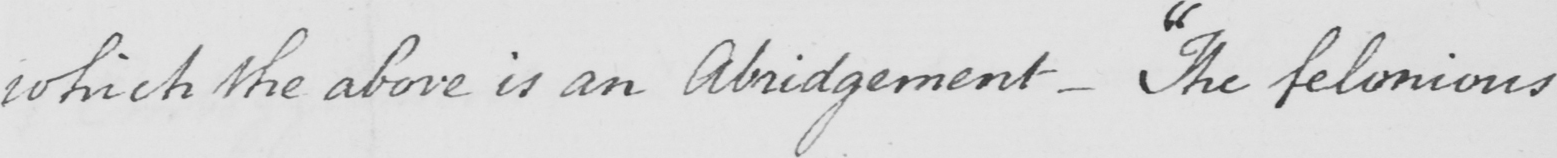What text is written in this handwritten line? which the above in an Abridgement  _   " The felonious 